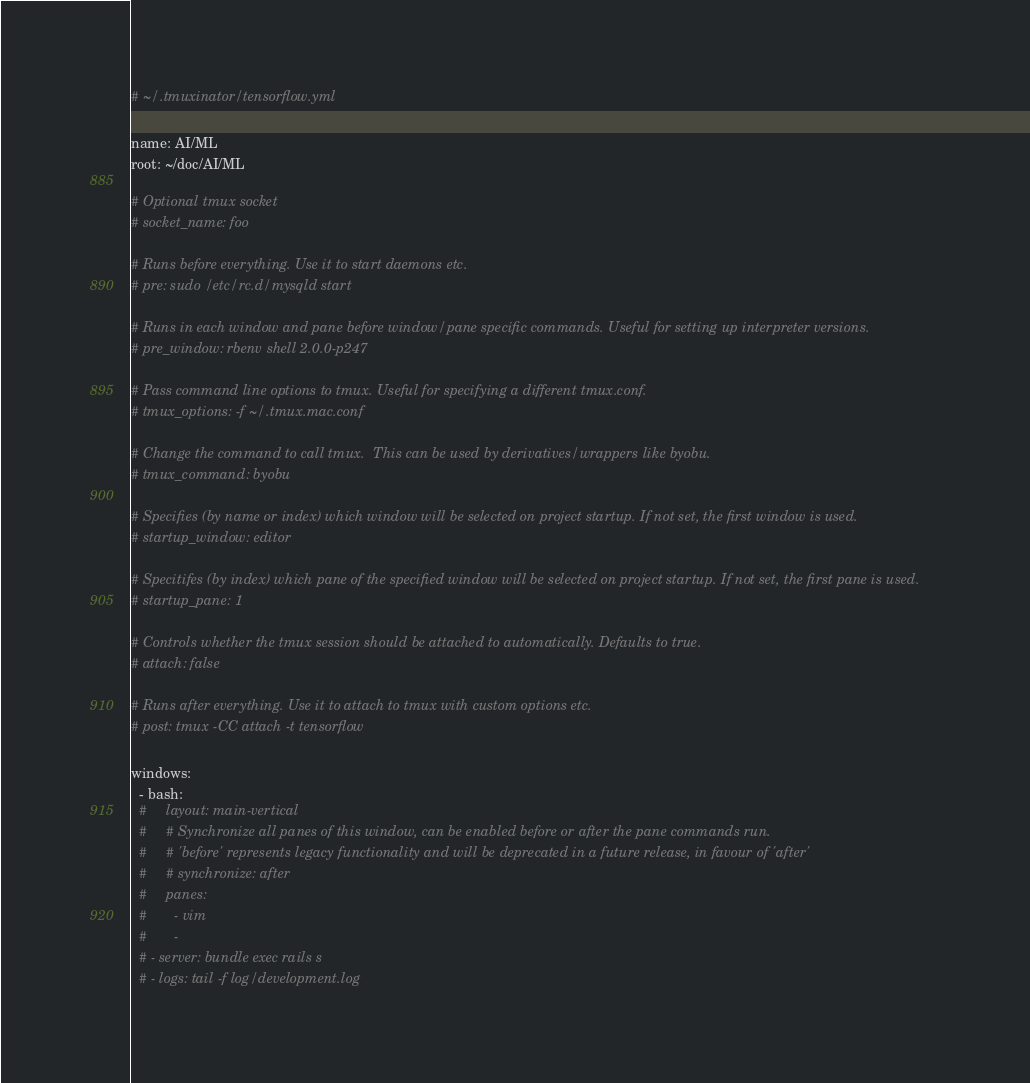<code> <loc_0><loc_0><loc_500><loc_500><_YAML_># ~/.tmuxinator/tensorflow.yml

name: AI/ML
root: ~/doc/AI/ML

# Optional tmux socket
# socket_name: foo

# Runs before everything. Use it to start daemons etc.
# pre: sudo /etc/rc.d/mysqld start

# Runs in each window and pane before window/pane specific commands. Useful for setting up interpreter versions.
# pre_window: rbenv shell 2.0.0-p247

# Pass command line options to tmux. Useful for specifying a different tmux.conf.
# tmux_options: -f ~/.tmux.mac.conf

# Change the command to call tmux.  This can be used by derivatives/wrappers like byobu.
# tmux_command: byobu

# Specifies (by name or index) which window will be selected on project startup. If not set, the first window is used.
# startup_window: editor

# Specitifes (by index) which pane of the specified window will be selected on project startup. If not set, the first pane is used.
# startup_pane: 1

# Controls whether the tmux session should be attached to automatically. Defaults to true.
# attach: false

# Runs after everything. Use it to attach to tmux with custom options etc.
# post: tmux -CC attach -t tensorflow

windows:
  - bash:
  #     layout: main-vertical
  #     # Synchronize all panes of this window, can be enabled before or after the pane commands run.
  #     # 'before' represents legacy functionality and will be deprecated in a future release, in favour of 'after'
  #     # synchronize: after
  #     panes:
  #       - vim
  #       - 
  # - server: bundle exec rails s
  # - logs: tail -f log/development.log
</code> 